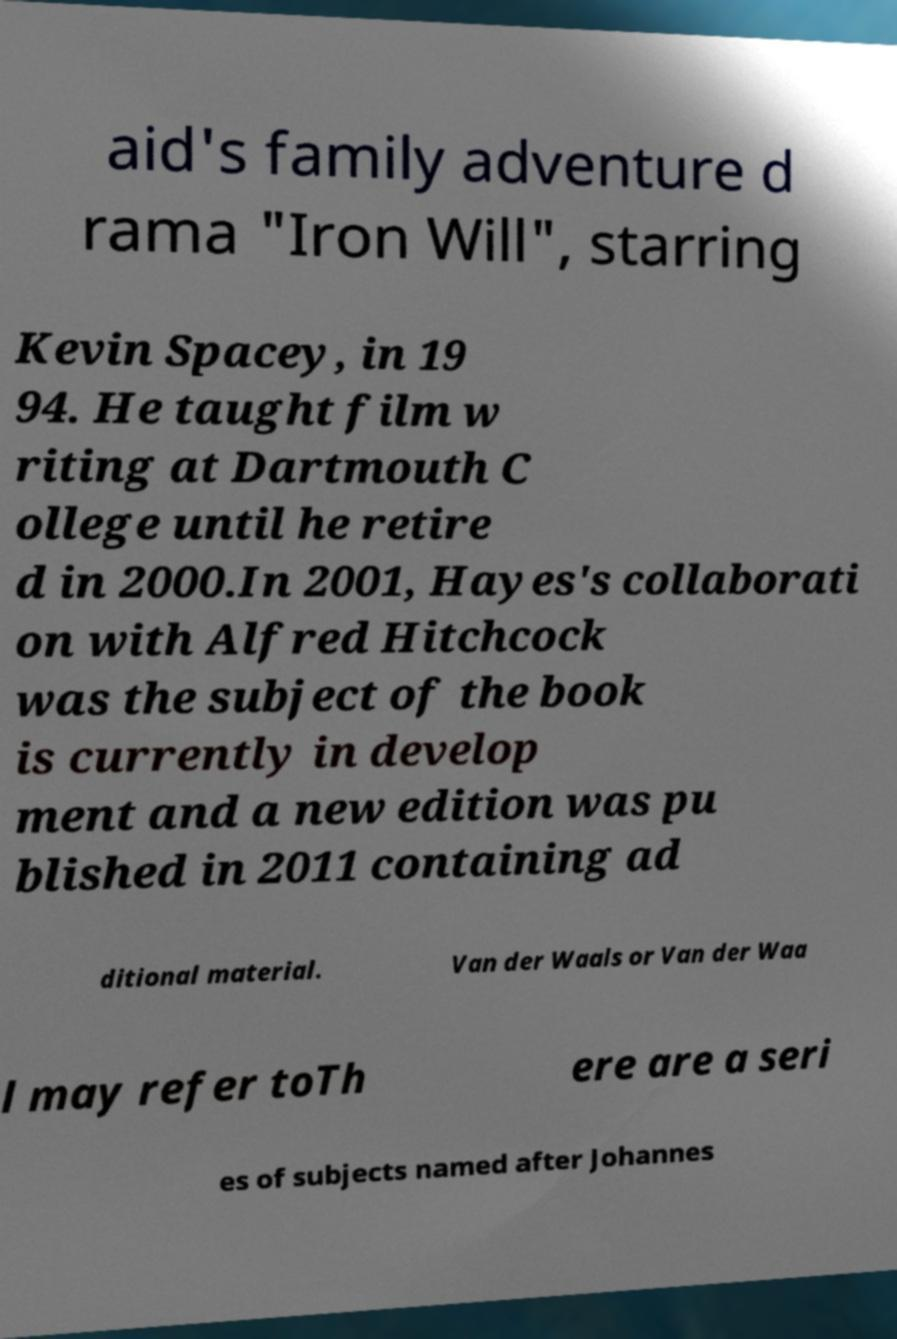Please read and relay the text visible in this image. What does it say? aid's family adventure d rama "Iron Will", starring Kevin Spacey, in 19 94. He taught film w riting at Dartmouth C ollege until he retire d in 2000.In 2001, Hayes's collaborati on with Alfred Hitchcock was the subject of the book is currently in develop ment and a new edition was pu blished in 2011 containing ad ditional material. Van der Waals or Van der Waa l may refer toTh ere are a seri es of subjects named after Johannes 